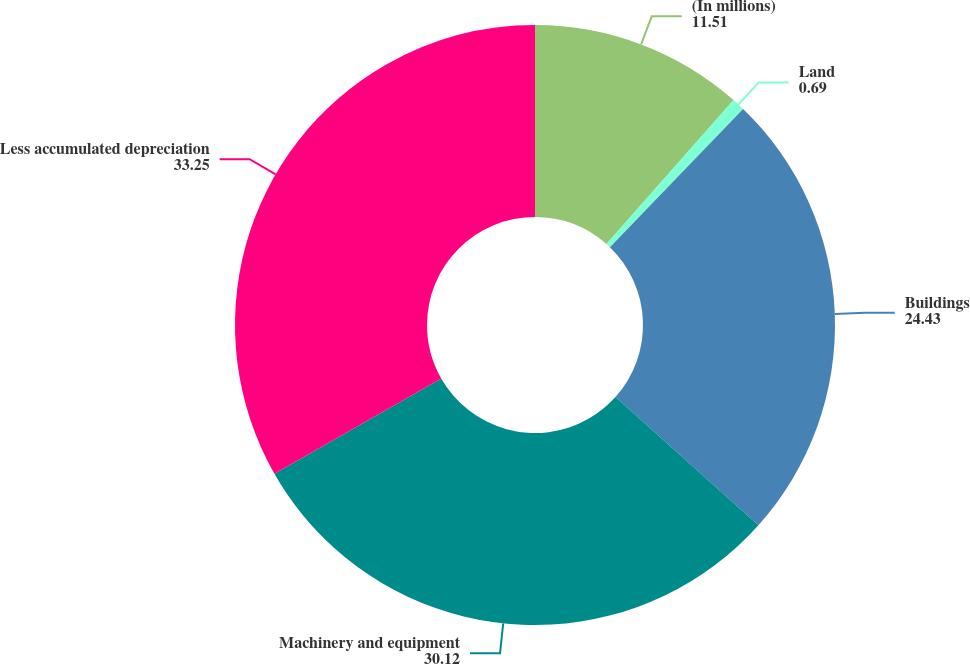Convert chart to OTSL. <chart><loc_0><loc_0><loc_500><loc_500><pie_chart><fcel>(In millions)<fcel>Land<fcel>Buildings<fcel>Machinery and equipment<fcel>Less accumulated depreciation<nl><fcel>11.51%<fcel>0.69%<fcel>24.43%<fcel>30.12%<fcel>33.25%<nl></chart> 